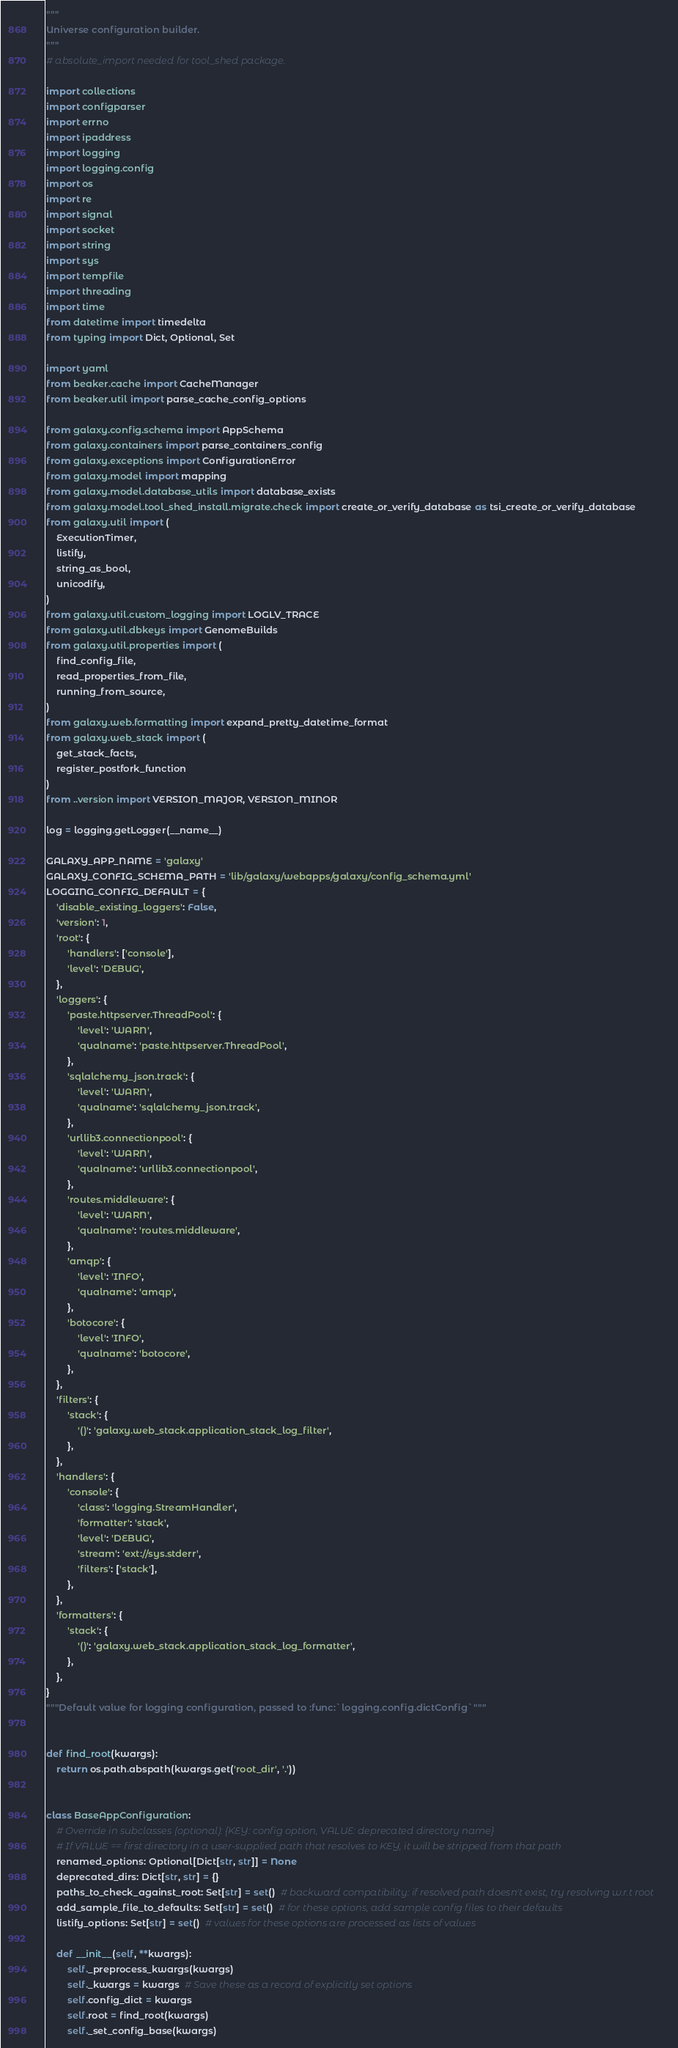Convert code to text. <code><loc_0><loc_0><loc_500><loc_500><_Python_>"""
Universe configuration builder.
"""
# absolute_import needed for tool_shed package.

import collections
import configparser
import errno
import ipaddress
import logging
import logging.config
import os
import re
import signal
import socket
import string
import sys
import tempfile
import threading
import time
from datetime import timedelta
from typing import Dict, Optional, Set

import yaml
from beaker.cache import CacheManager
from beaker.util import parse_cache_config_options

from galaxy.config.schema import AppSchema
from galaxy.containers import parse_containers_config
from galaxy.exceptions import ConfigurationError
from galaxy.model import mapping
from galaxy.model.database_utils import database_exists
from galaxy.model.tool_shed_install.migrate.check import create_or_verify_database as tsi_create_or_verify_database
from galaxy.util import (
    ExecutionTimer,
    listify,
    string_as_bool,
    unicodify,
)
from galaxy.util.custom_logging import LOGLV_TRACE
from galaxy.util.dbkeys import GenomeBuilds
from galaxy.util.properties import (
    find_config_file,
    read_properties_from_file,
    running_from_source,
)
from galaxy.web.formatting import expand_pretty_datetime_format
from galaxy.web_stack import (
    get_stack_facts,
    register_postfork_function
)
from ..version import VERSION_MAJOR, VERSION_MINOR

log = logging.getLogger(__name__)

GALAXY_APP_NAME = 'galaxy'
GALAXY_CONFIG_SCHEMA_PATH = 'lib/galaxy/webapps/galaxy/config_schema.yml'
LOGGING_CONFIG_DEFAULT = {
    'disable_existing_loggers': False,
    'version': 1,
    'root': {
        'handlers': ['console'],
        'level': 'DEBUG',
    },
    'loggers': {
        'paste.httpserver.ThreadPool': {
            'level': 'WARN',
            'qualname': 'paste.httpserver.ThreadPool',
        },
        'sqlalchemy_json.track': {
            'level': 'WARN',
            'qualname': 'sqlalchemy_json.track',
        },
        'urllib3.connectionpool': {
            'level': 'WARN',
            'qualname': 'urllib3.connectionpool',
        },
        'routes.middleware': {
            'level': 'WARN',
            'qualname': 'routes.middleware',
        },
        'amqp': {
            'level': 'INFO',
            'qualname': 'amqp',
        },
        'botocore': {
            'level': 'INFO',
            'qualname': 'botocore',
        },
    },
    'filters': {
        'stack': {
            '()': 'galaxy.web_stack.application_stack_log_filter',
        },
    },
    'handlers': {
        'console': {
            'class': 'logging.StreamHandler',
            'formatter': 'stack',
            'level': 'DEBUG',
            'stream': 'ext://sys.stderr',
            'filters': ['stack'],
        },
    },
    'formatters': {
        'stack': {
            '()': 'galaxy.web_stack.application_stack_log_formatter',
        },
    },
}
"""Default value for logging configuration, passed to :func:`logging.config.dictConfig`"""


def find_root(kwargs):
    return os.path.abspath(kwargs.get('root_dir', '.'))


class BaseAppConfiguration:
    # Override in subclasses (optional): {KEY: config option, VALUE: deprecated directory name}
    # If VALUE == first directory in a user-supplied path that resolves to KEY, it will be stripped from that path
    renamed_options: Optional[Dict[str, str]] = None
    deprecated_dirs: Dict[str, str] = {}
    paths_to_check_against_root: Set[str] = set()  # backward compatibility: if resolved path doesn't exist, try resolving w.r.t root
    add_sample_file_to_defaults: Set[str] = set()  # for these options, add sample config files to their defaults
    listify_options: Set[str] = set()  # values for these options are processed as lists of values

    def __init__(self, **kwargs):
        self._preprocess_kwargs(kwargs)
        self._kwargs = kwargs  # Save these as a record of explicitly set options
        self.config_dict = kwargs
        self.root = find_root(kwargs)
        self._set_config_base(kwargs)</code> 